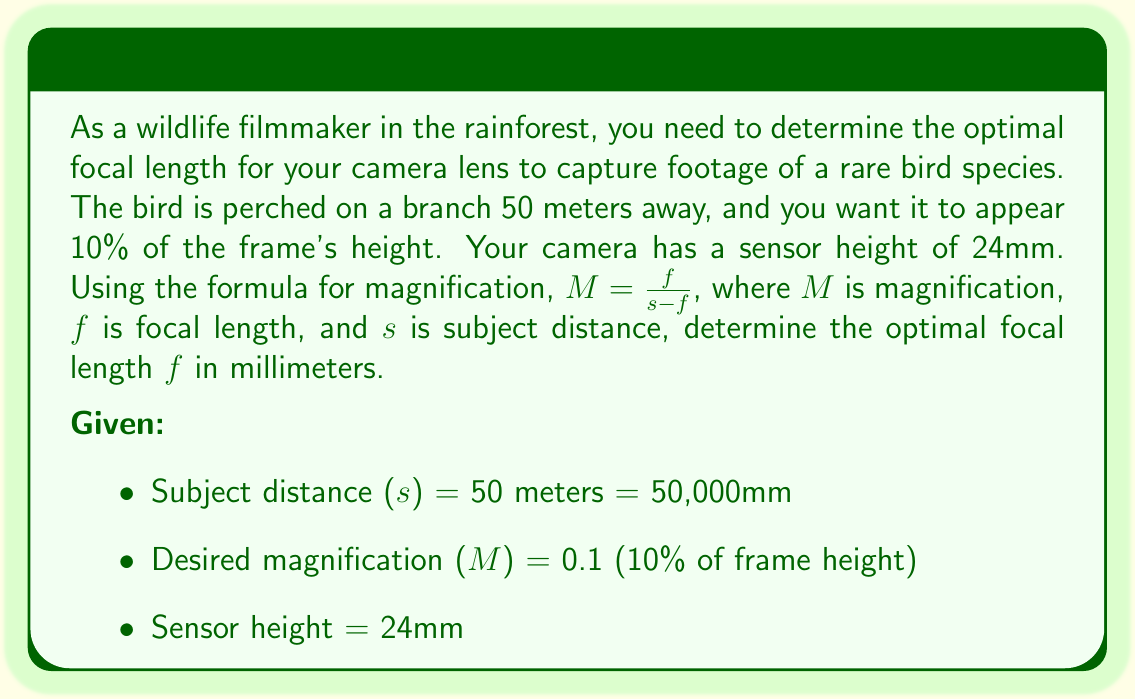Can you solve this math problem? To solve this problem, we'll use the magnification formula and follow these steps:

1) We start with the magnification formula: $M = \frac{f}{s-f}$

2) We know that $M = 0.1$ and $s = 50,000mm$. Let's substitute these values:

   $0.1 = \frac{f}{50000-f}$

3) Now, let's cross-multiply to isolate $f$:

   $0.1(50000-f) = f$

4) Distribute on the left side:

   $5000 - 0.1f = f$

5) Add $0.1f$ to both sides:

   $5000 = 1.1f$

6) Finally, divide both sides by 1.1:

   $\frac{5000}{1.1} = f$

7) Calculate the result:

   $f \approx 4545.45mm$

Therefore, the optimal focal length is approximately 4545mm or 4.55 meters.

To verify, we can check if this focal length will make the bird appear 10% of the frame height:

Frame height in real life = $\frac{24mm}{0.1} = 240mm$

At 50 meters away, this 240mm would indeed be about 10% of the frame height.
Answer: The optimal focal length is approximately 4545mm or 4.55 meters. 